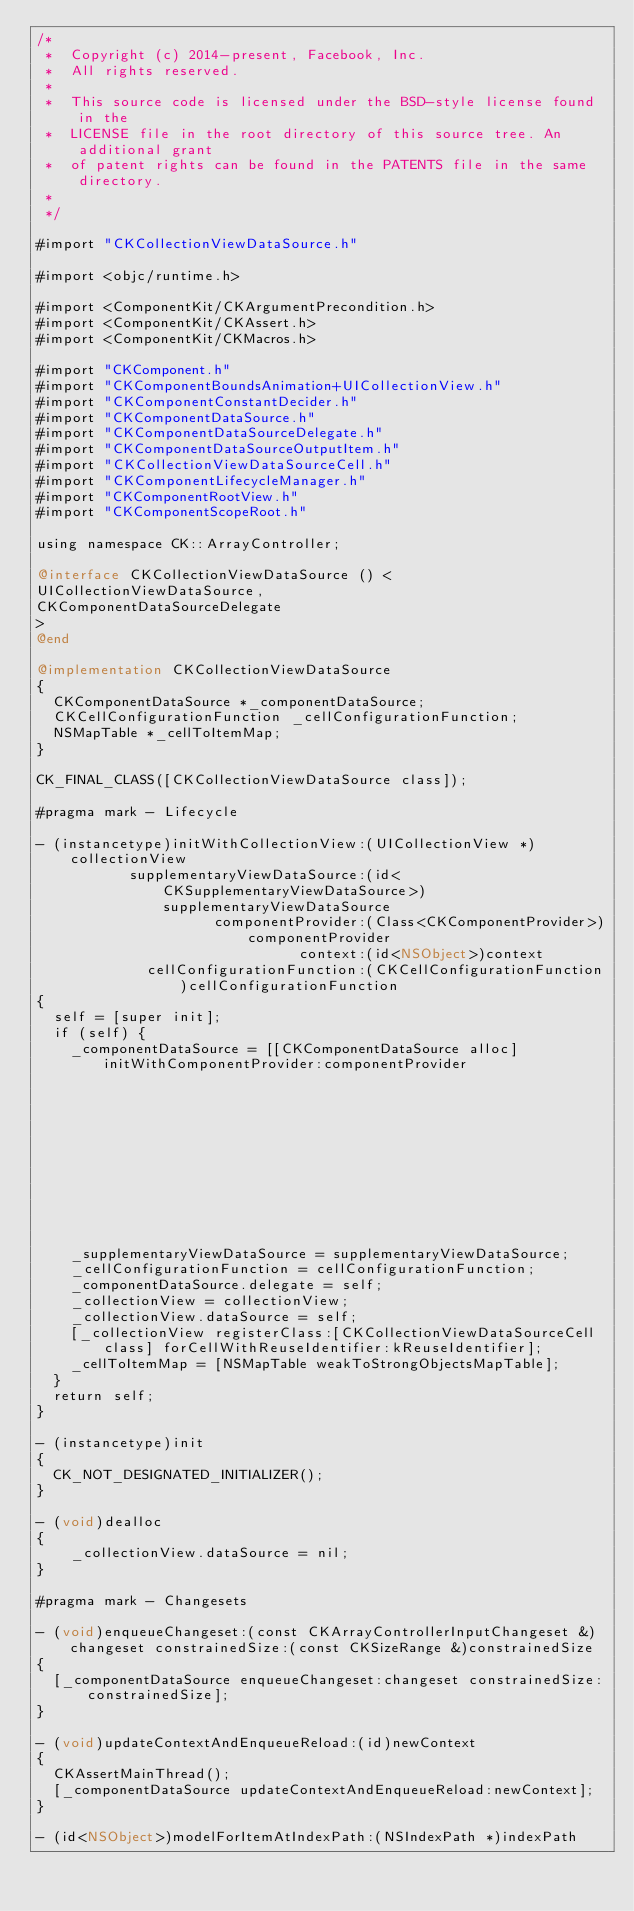Convert code to text. <code><loc_0><loc_0><loc_500><loc_500><_ObjectiveC_>/*
 *  Copyright (c) 2014-present, Facebook, Inc.
 *  All rights reserved.
 *
 *  This source code is licensed under the BSD-style license found in the
 *  LICENSE file in the root directory of this source tree. An additional grant
 *  of patent rights can be found in the PATENTS file in the same directory.
 *
 */

#import "CKCollectionViewDataSource.h"

#import <objc/runtime.h>

#import <ComponentKit/CKArgumentPrecondition.h>
#import <ComponentKit/CKAssert.h>
#import <ComponentKit/CKMacros.h>

#import "CKComponent.h"
#import "CKComponentBoundsAnimation+UICollectionView.h"
#import "CKComponentConstantDecider.h"
#import "CKComponentDataSource.h"
#import "CKComponentDataSourceDelegate.h"
#import "CKComponentDataSourceOutputItem.h"
#import "CKCollectionViewDataSourceCell.h"
#import "CKComponentLifecycleManager.h"
#import "CKComponentRootView.h"
#import "CKComponentScopeRoot.h"

using namespace CK::ArrayController;

@interface CKCollectionViewDataSource () <
UICollectionViewDataSource,
CKComponentDataSourceDelegate
>
@end

@implementation CKCollectionViewDataSource
{
  CKComponentDataSource *_componentDataSource;
  CKCellConfigurationFunction _cellConfigurationFunction;
  NSMapTable *_cellToItemMap;
}

CK_FINAL_CLASS([CKCollectionViewDataSource class]);

#pragma mark - Lifecycle

- (instancetype)initWithCollectionView:(UICollectionView *)collectionView
           supplementaryViewDataSource:(id<CKSupplementaryViewDataSource>)supplementaryViewDataSource
                     componentProvider:(Class<CKComponentProvider>)componentProvider
                               context:(id<NSObject>)context
             cellConfigurationFunction:(CKCellConfigurationFunction)cellConfigurationFunction
{
  self = [super init];
  if (self) {
    _componentDataSource = [[CKComponentDataSource alloc] initWithComponentProvider:componentProvider
                                                                            context:context
                                                                            decider:[CKComponentConstantApprovingDecider class]];
    _supplementaryViewDataSource = supplementaryViewDataSource;
    _cellConfigurationFunction = cellConfigurationFunction;
    _componentDataSource.delegate = self;
    _collectionView = collectionView;
    _collectionView.dataSource = self;
    [_collectionView registerClass:[CKCollectionViewDataSourceCell class] forCellWithReuseIdentifier:kReuseIdentifier];
    _cellToItemMap = [NSMapTable weakToStrongObjectsMapTable];
  }
  return self;
}

- (instancetype)init
{
  CK_NOT_DESIGNATED_INITIALIZER();
}

- (void)dealloc
{
    _collectionView.dataSource = nil;
}

#pragma mark - Changesets

- (void)enqueueChangeset:(const CKArrayControllerInputChangeset &)changeset constrainedSize:(const CKSizeRange &)constrainedSize
{
  [_componentDataSource enqueueChangeset:changeset constrainedSize:constrainedSize];
}

- (void)updateContextAndEnqueueReload:(id)newContext
{
  CKAssertMainThread();
  [_componentDataSource updateContextAndEnqueueReload:newContext];
}

- (id<NSObject>)modelForItemAtIndexPath:(NSIndexPath *)indexPath</code> 